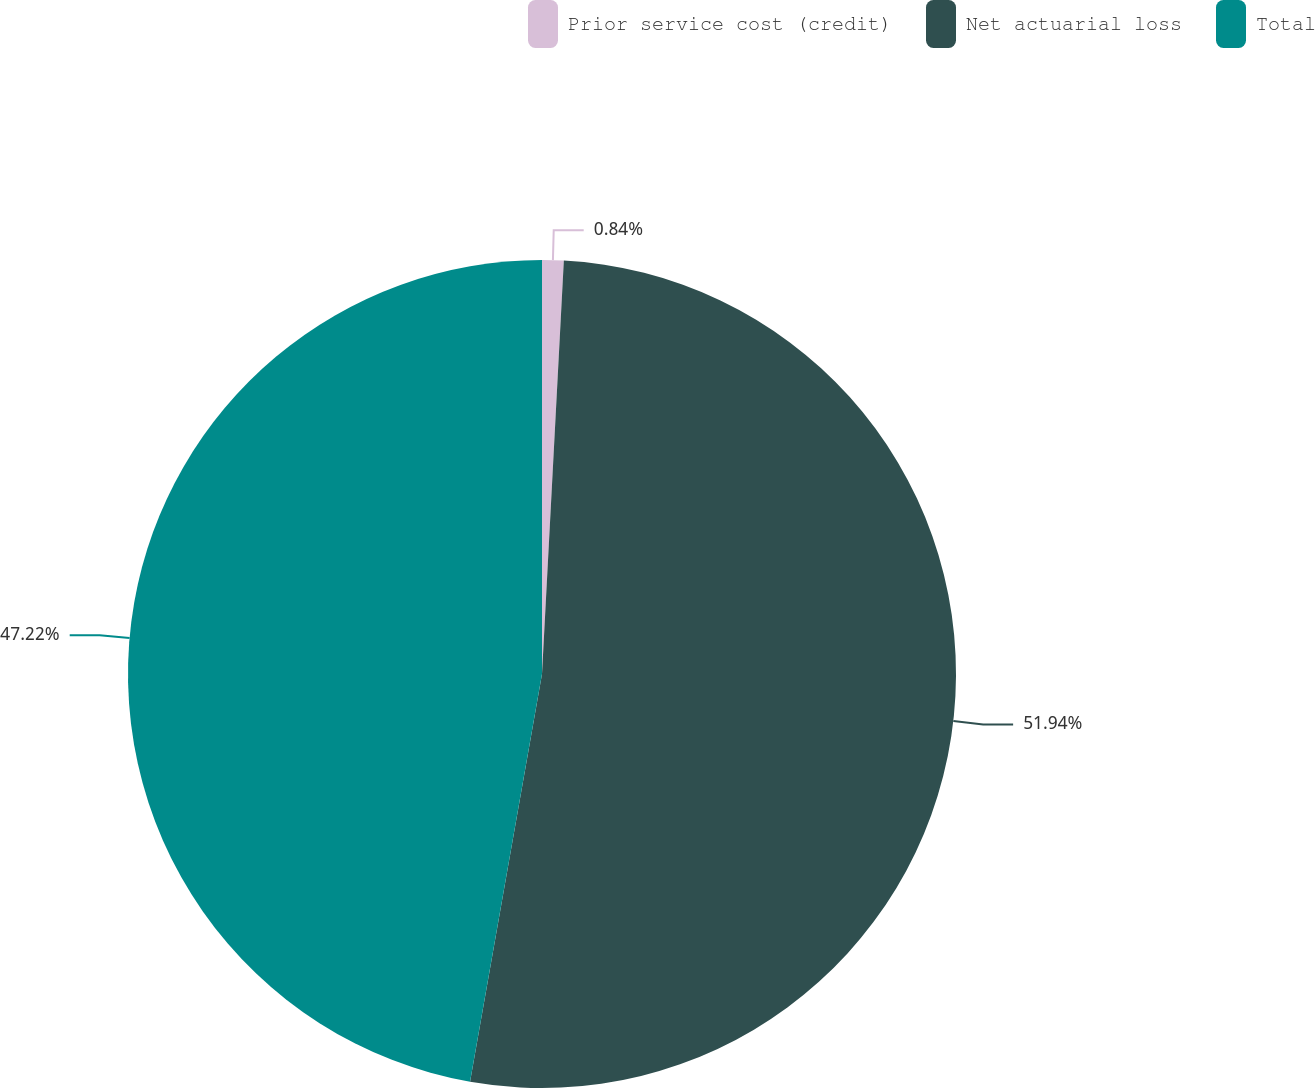Convert chart to OTSL. <chart><loc_0><loc_0><loc_500><loc_500><pie_chart><fcel>Prior service cost (credit)<fcel>Net actuarial loss<fcel>Total<nl><fcel>0.84%<fcel>51.94%<fcel>47.22%<nl></chart> 